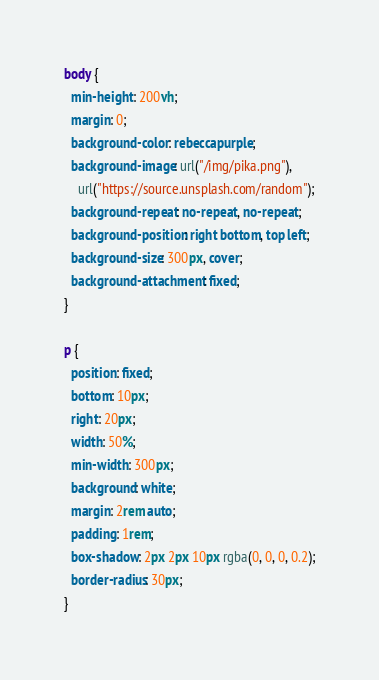Convert code to text. <code><loc_0><loc_0><loc_500><loc_500><_CSS_>body {
  min-height: 200vh;
  margin: 0;
  background-color: rebeccapurple;
  background-image: url("/img/pika.png"),
    url("https://source.unsplash.com/random");
  background-repeat: no-repeat, no-repeat;
  background-position: right bottom, top left;
  background-size: 300px, cover;
  background-attachment: fixed;
}

p {
  position: fixed;
  bottom: 10px;
  right: 20px;
  width: 50%;
  min-width: 300px;
  background: white;
  margin: 2rem auto;
  padding: 1rem;
  box-shadow: 2px 2px 10px rgba(0, 0, 0, 0.2);
  border-radius: 30px;
}
</code> 